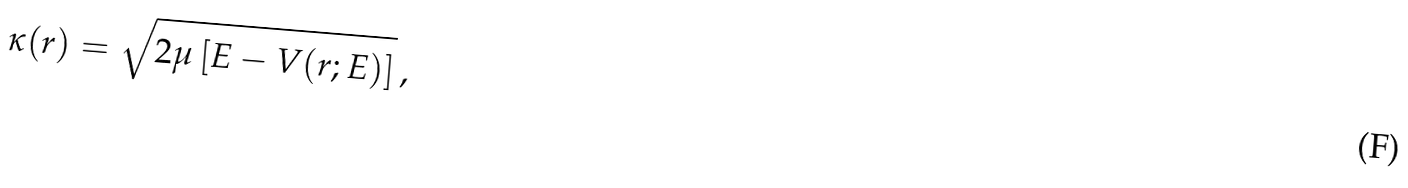<formula> <loc_0><loc_0><loc_500><loc_500>\kappa ( r ) = \sqrt { 2 \mu \left [ E - V ( r ; E ) \right ] } \, ,</formula> 